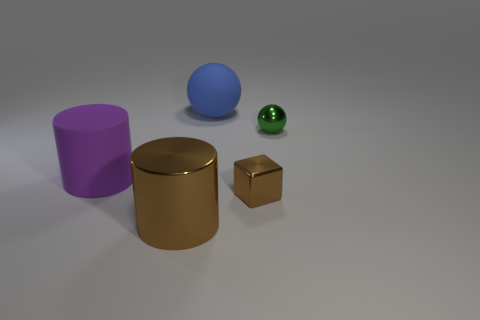There is a rubber object in front of the matte thing that is behind the tiny green sphere; is there a big thing on the right side of it?
Ensure brevity in your answer.  Yes. Do the tiny object that is in front of the purple object and the green object have the same shape?
Your answer should be compact. No. Are there fewer large brown cylinders behind the tiny green metal object than large metal cylinders that are left of the purple matte cylinder?
Give a very brief answer. No. What is the purple cylinder made of?
Offer a very short reply. Rubber. Is the color of the cube the same as the metal thing to the left of the matte ball?
Ensure brevity in your answer.  Yes. What number of big objects are to the left of the large metallic cylinder?
Your answer should be compact. 1. Are there fewer big purple cylinders right of the small brown thing than large cylinders?
Offer a terse response. Yes. The tiny ball is what color?
Keep it short and to the point. Green. There is a metallic thing that is to the left of the rubber ball; does it have the same color as the cube?
Your answer should be compact. Yes. What is the color of the large rubber thing that is the same shape as the small green object?
Provide a short and direct response. Blue. 